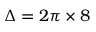<formula> <loc_0><loc_0><loc_500><loc_500>\Delta = 2 \pi \times 8</formula> 